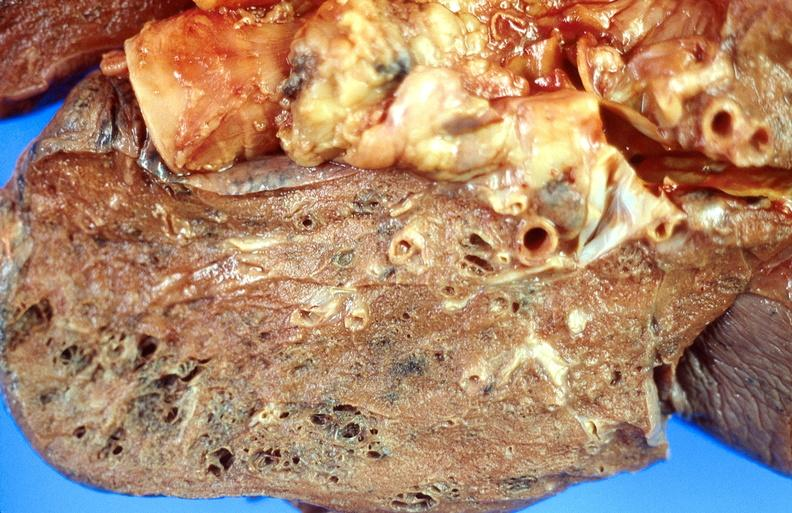does lesion show cryptococcal pneumonia?
Answer the question using a single word or phrase. No 